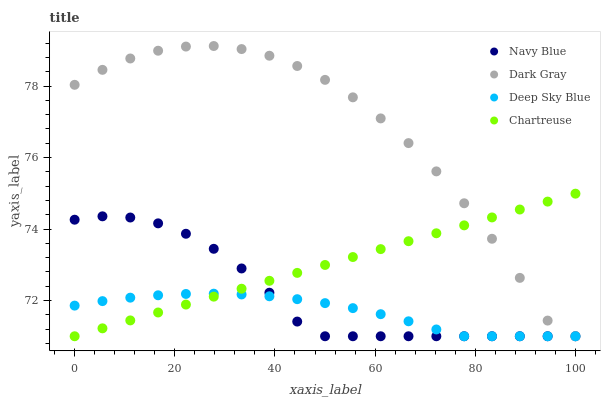Does Deep Sky Blue have the minimum area under the curve?
Answer yes or no. Yes. Does Dark Gray have the maximum area under the curve?
Answer yes or no. Yes. Does Navy Blue have the minimum area under the curve?
Answer yes or no. No. Does Navy Blue have the maximum area under the curve?
Answer yes or no. No. Is Chartreuse the smoothest?
Answer yes or no. Yes. Is Dark Gray the roughest?
Answer yes or no. Yes. Is Navy Blue the smoothest?
Answer yes or no. No. Is Navy Blue the roughest?
Answer yes or no. No. Does Dark Gray have the lowest value?
Answer yes or no. Yes. Does Dark Gray have the highest value?
Answer yes or no. Yes. Does Navy Blue have the highest value?
Answer yes or no. No. Does Chartreuse intersect Dark Gray?
Answer yes or no. Yes. Is Chartreuse less than Dark Gray?
Answer yes or no. No. Is Chartreuse greater than Dark Gray?
Answer yes or no. No. 